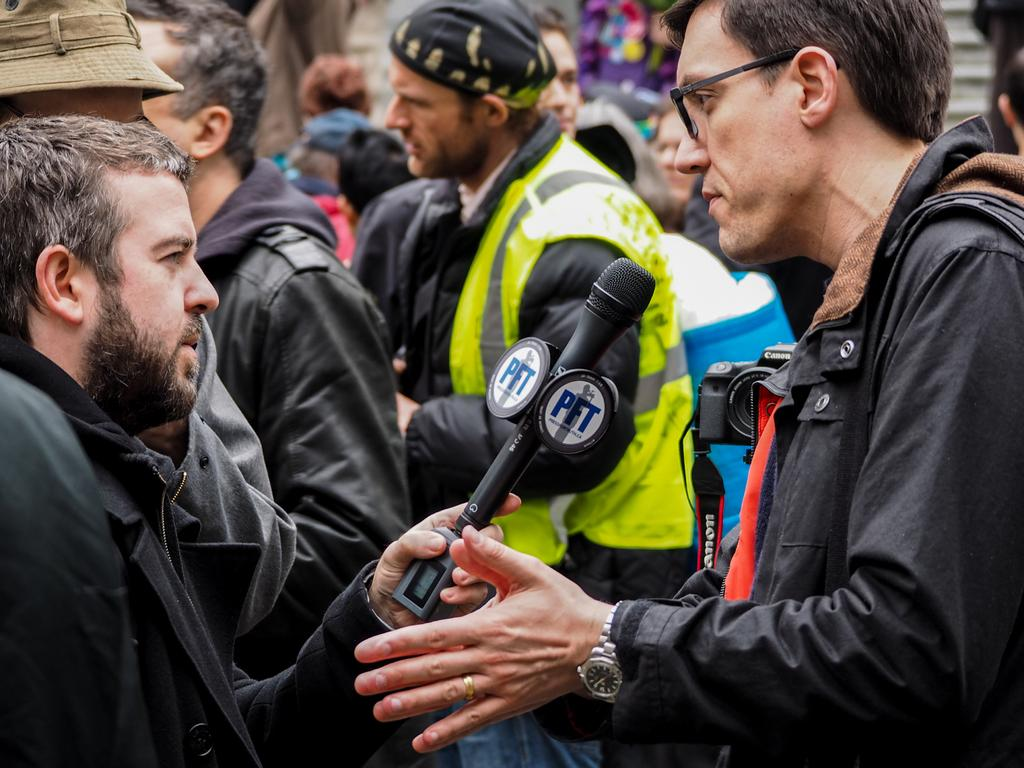What is happening in the image involving multiple people? There are groups of people in the image. Where are the people located in the image? The people are standing on a path. Can you identify any specific person in the image? Yes, there is a person holding a microphone in the image. What type of drain can be seen in the image? There is no drain present in the image. Can you tell me how many animals are visible in the zoo in the image? There is no zoo present in the image. 